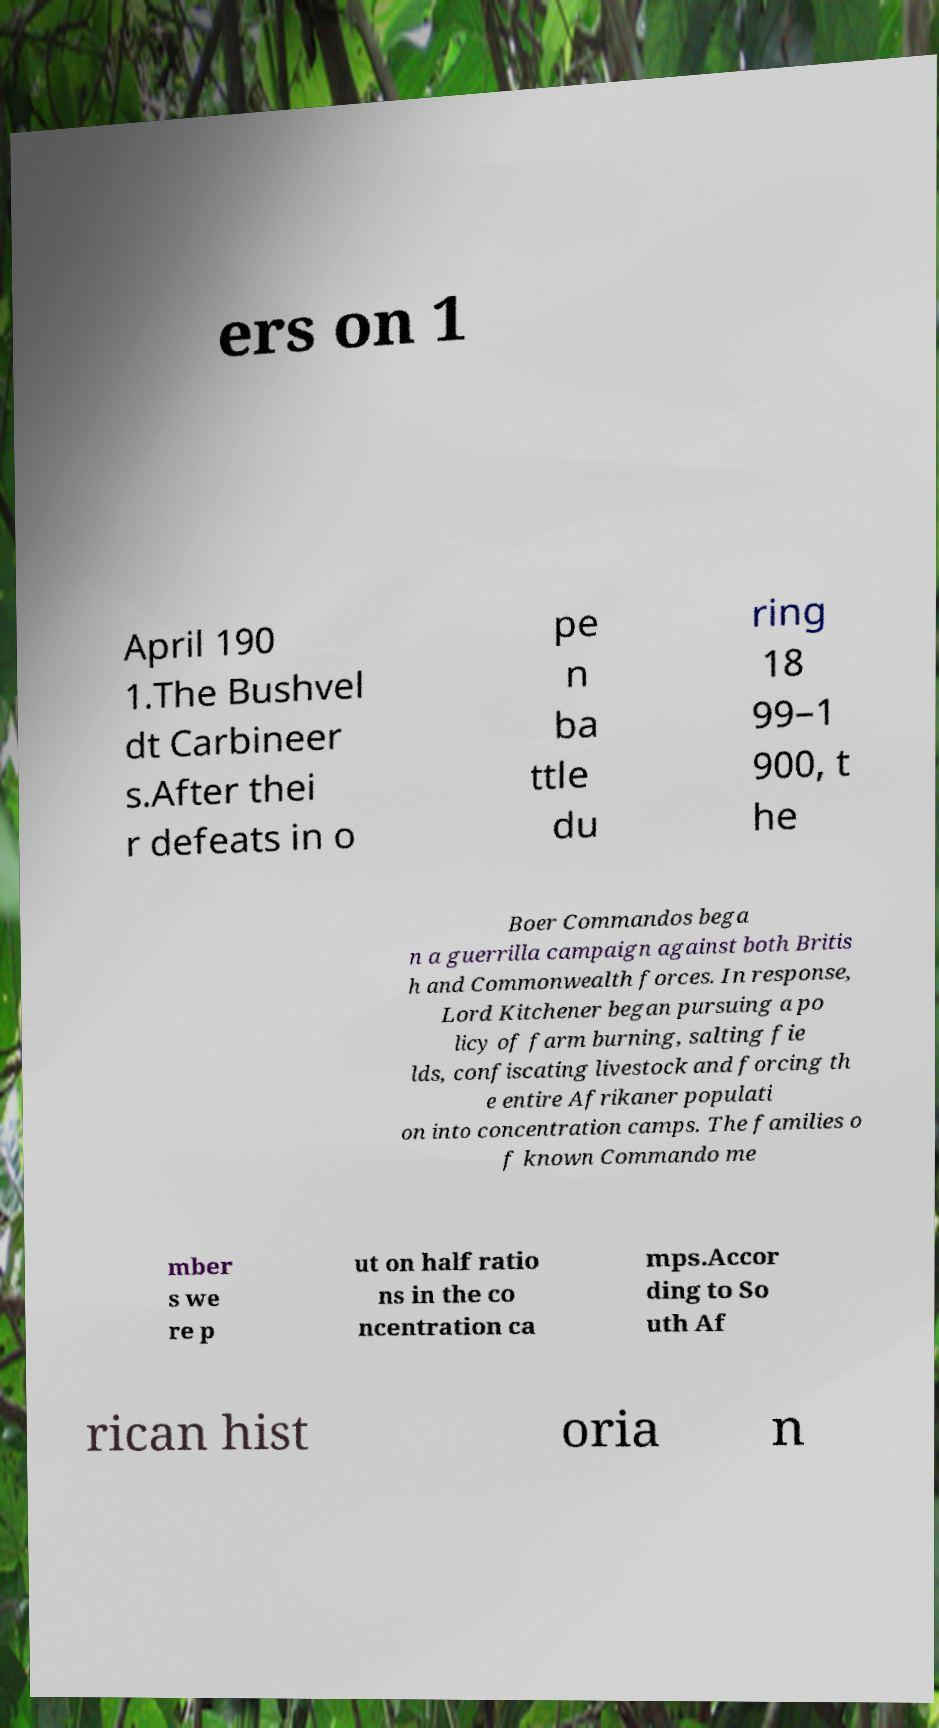For documentation purposes, I need the text within this image transcribed. Could you provide that? ers on 1 April 190 1.The Bushvel dt Carbineer s.After thei r defeats in o pe n ba ttle du ring 18 99–1 900, t he Boer Commandos bega n a guerrilla campaign against both Britis h and Commonwealth forces. In response, Lord Kitchener began pursuing a po licy of farm burning, salting fie lds, confiscating livestock and forcing th e entire Afrikaner populati on into concentration camps. The families o f known Commando me mber s we re p ut on half ratio ns in the co ncentration ca mps.Accor ding to So uth Af rican hist oria n 